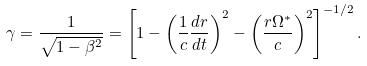<formula> <loc_0><loc_0><loc_500><loc_500>\gamma = \frac { 1 } { \sqrt { 1 - \beta ^ { 2 } } } = \left [ 1 - \left ( \frac { 1 } { c } \frac { d r } { d t } \right ) ^ { 2 } - \left ( \frac { r \Omega ^ { * } } { c } \right ) ^ { 2 } \right ] ^ { - 1 / 2 } .</formula> 